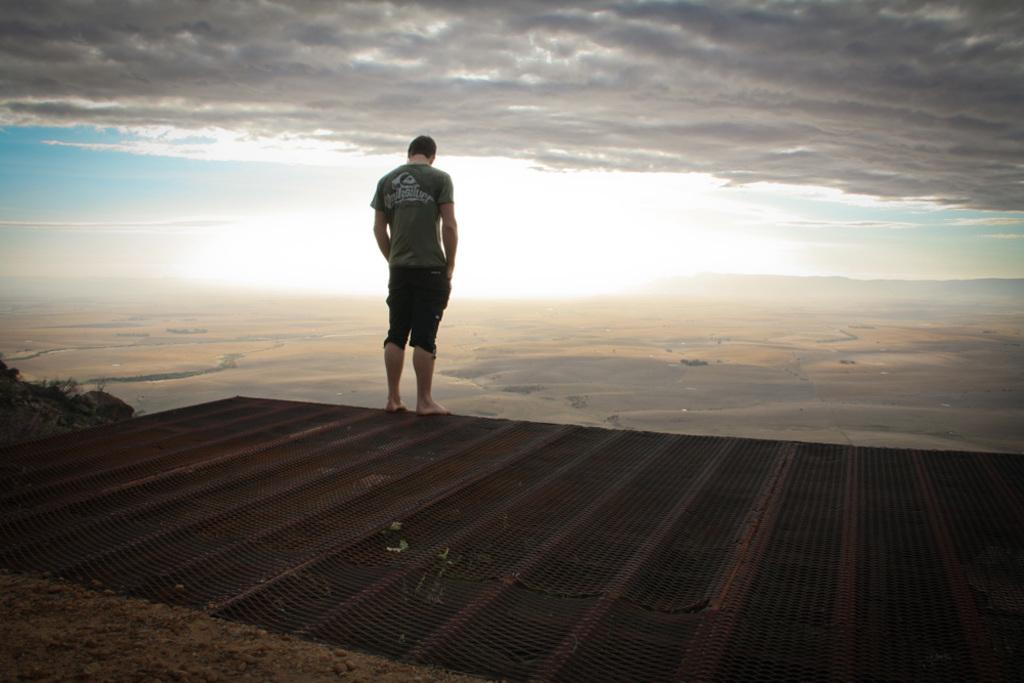What is the man doing in the image? The man is standing on a metal grill in the image. What can be seen at the top of the image? The sky is visible at the top of the image. What type of surface is at the bottom of the image? Sand is present at the bottom of the image. What type of vegetation is on the left side of the image? There are small plants on the left side of the image. What type of food is the man sharing with his sisters in the image? There is no mention of food or sisters in the image; it only shows a man standing on a metal grill with a sky and sand visible. 